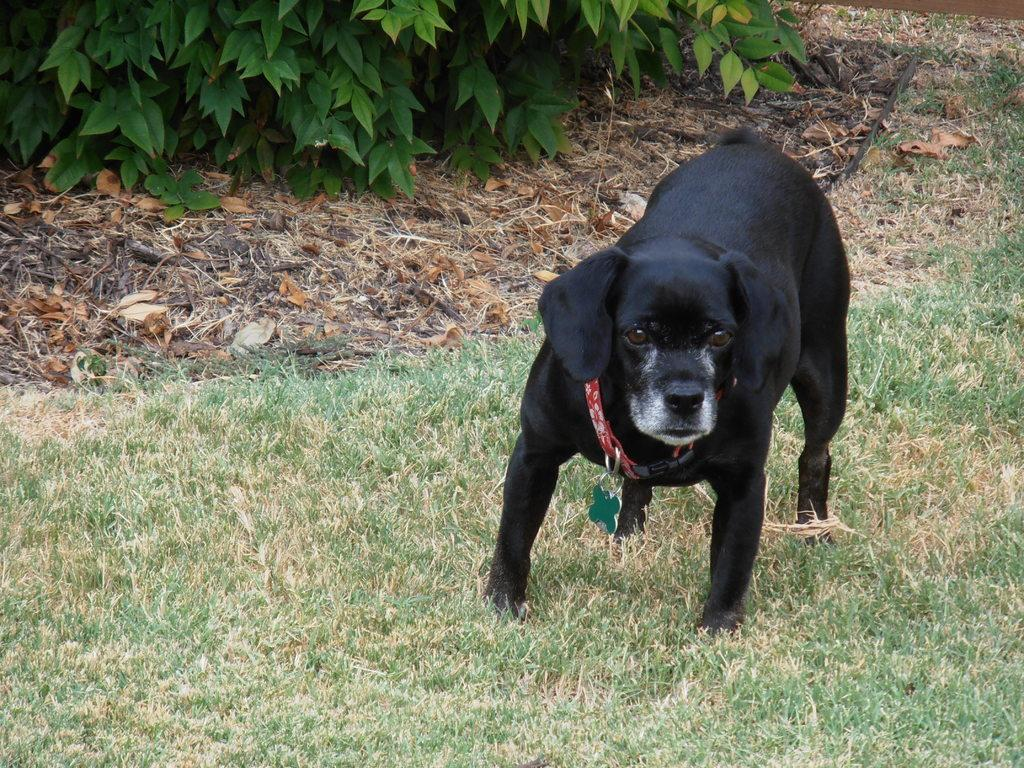What animal can be seen in the picture? There is a dog in the picture. Where is the dog located? The dog is on the grass. What type of vegetation is present in the picture? There are plants in the picture. What type of wood is the dog using to connect with the verse in the picture? There is no wood, connection, or verse present in the picture; it only features a dog on the grass with plants nearby. 